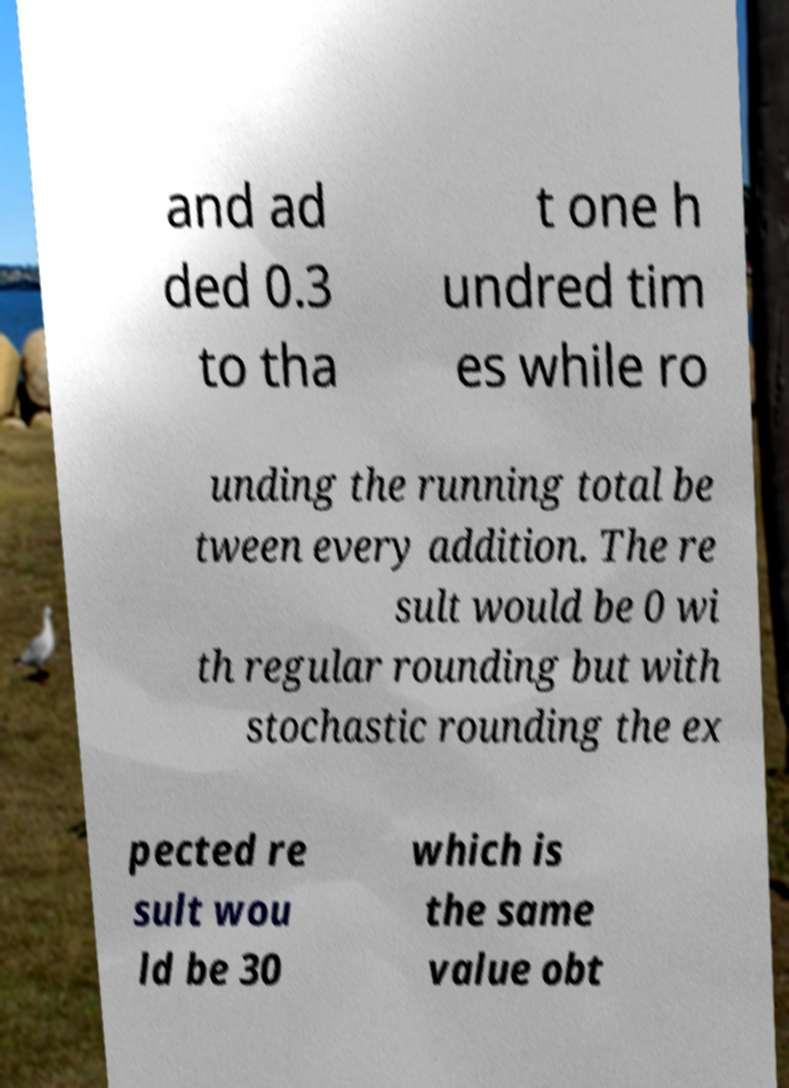Can you read and provide the text displayed in the image?This photo seems to have some interesting text. Can you extract and type it out for me? and ad ded 0.3 to tha t one h undred tim es while ro unding the running total be tween every addition. The re sult would be 0 wi th regular rounding but with stochastic rounding the ex pected re sult wou ld be 30 which is the same value obt 